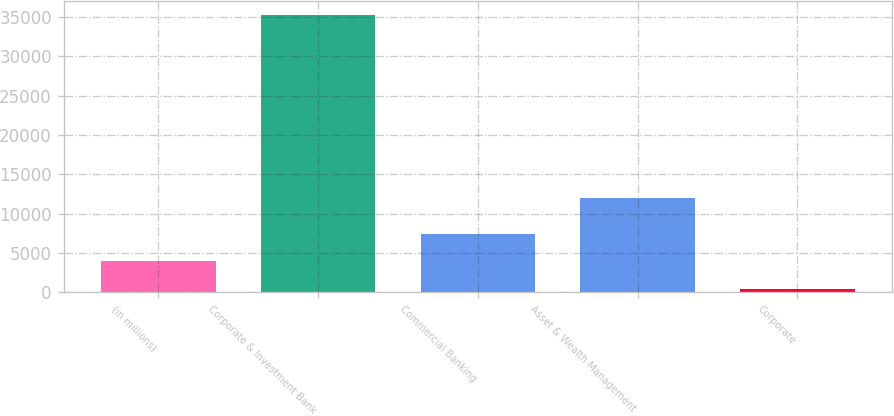Convert chart. <chart><loc_0><loc_0><loc_500><loc_500><bar_chart><fcel>(in millions)<fcel>Corporate & Investment Bank<fcel>Commercial Banking<fcel>Asset & Wealth Management<fcel>Corporate<nl><fcel>3959.9<fcel>35216<fcel>7453<fcel>12045<fcel>487<nl></chart> 